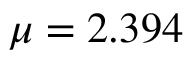Convert formula to latex. <formula><loc_0><loc_0><loc_500><loc_500>\mu = 2 . 3 9 4</formula> 